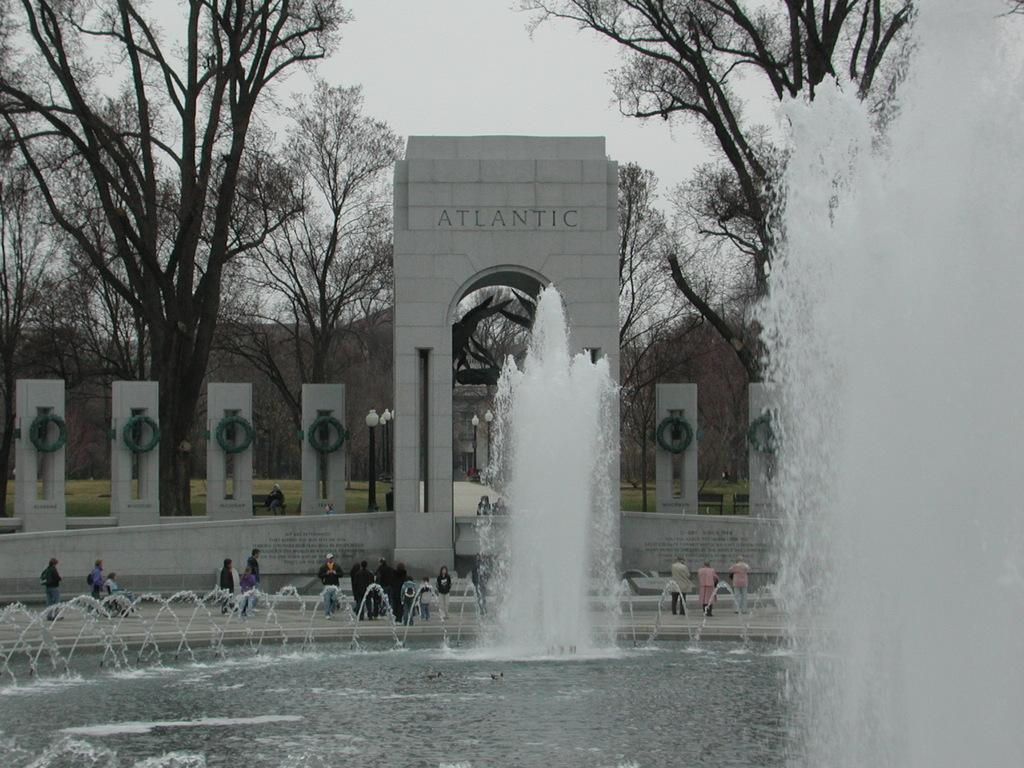What type of structure can be seen in the image? There is an arch and pillars in the image, which suggests a building or monument. What other elements are present in the image? There are trees, people, and a fountain in the image. What is the color of the sky in the image? The sky appears to be white in color. What is the average income of the people in the image? There is no information about the income of the people in the image, as it is not relevant to the visual content. 